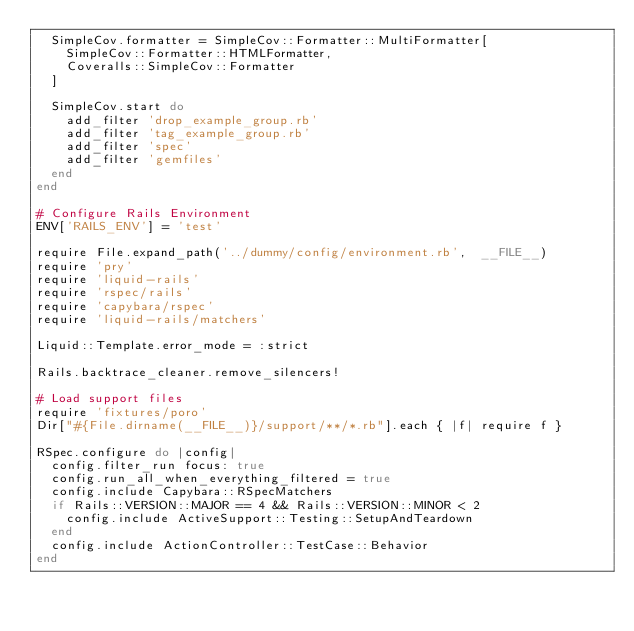<code> <loc_0><loc_0><loc_500><loc_500><_Ruby_>  SimpleCov.formatter = SimpleCov::Formatter::MultiFormatter[
    SimpleCov::Formatter::HTMLFormatter,
    Coveralls::SimpleCov::Formatter
  ]

  SimpleCov.start do
    add_filter 'drop_example_group.rb'
    add_filter 'tag_example_group.rb'
    add_filter 'spec'
    add_filter 'gemfiles'
  end
end

# Configure Rails Environment
ENV['RAILS_ENV'] = 'test'

require File.expand_path('../dummy/config/environment.rb',  __FILE__)
require 'pry'
require 'liquid-rails'
require 'rspec/rails'
require 'capybara/rspec'
require 'liquid-rails/matchers'

Liquid::Template.error_mode = :strict

Rails.backtrace_cleaner.remove_silencers!

# Load support files
require 'fixtures/poro'
Dir["#{File.dirname(__FILE__)}/support/**/*.rb"].each { |f| require f }

RSpec.configure do |config|
  config.filter_run focus: true
  config.run_all_when_everything_filtered = true
  config.include Capybara::RSpecMatchers
  if Rails::VERSION::MAJOR == 4 && Rails::VERSION::MINOR < 2
    config.include ActiveSupport::Testing::SetupAndTeardown
  end
  config.include ActionController::TestCase::Behavior
end</code> 